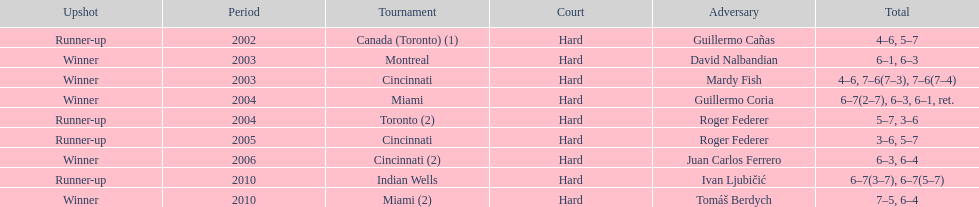Was roddick a runner-up or winner more? Winner. 